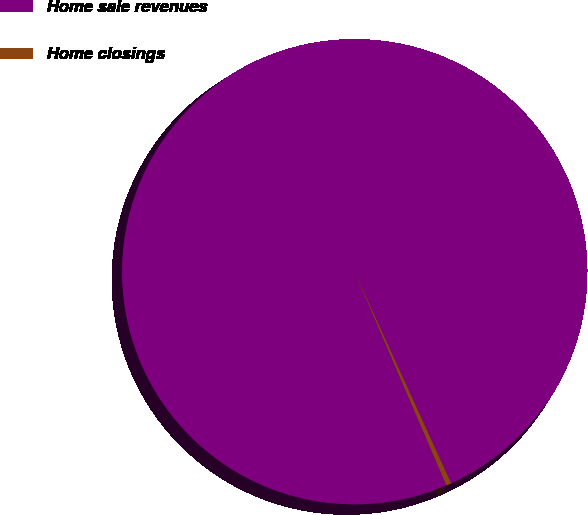Convert chart. <chart><loc_0><loc_0><loc_500><loc_500><pie_chart><fcel>Home sale revenues<fcel>Home closings<nl><fcel>99.64%<fcel>0.36%<nl></chart> 